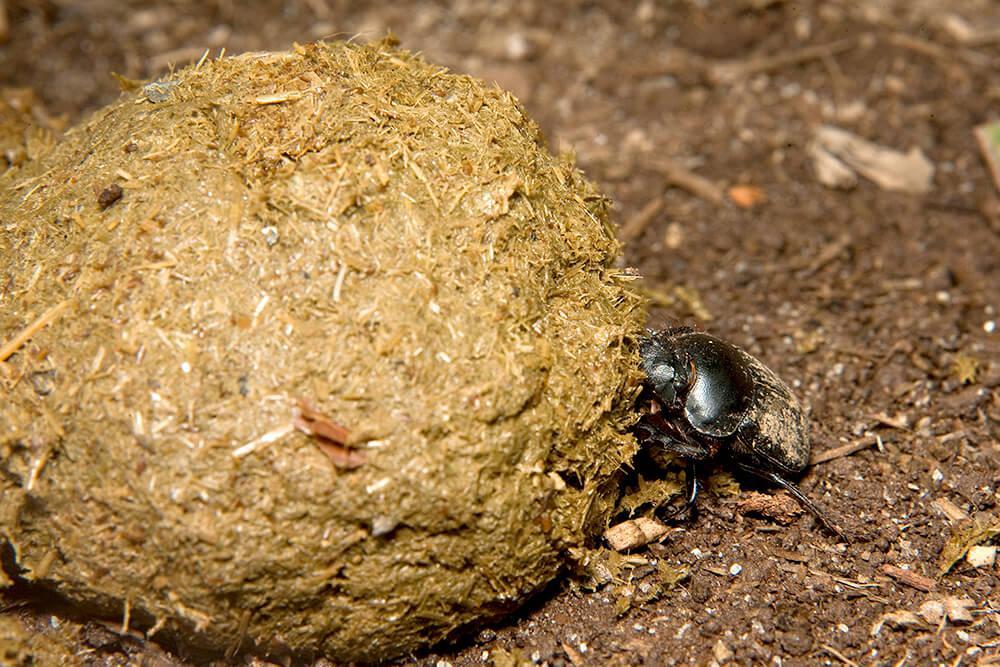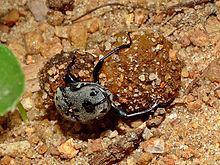The first image is the image on the left, the second image is the image on the right. Evaluate the accuracy of this statement regarding the images: "There is exactly one insect standing on top of the ball in one of the images.". Is it true? Answer yes or no. No. 